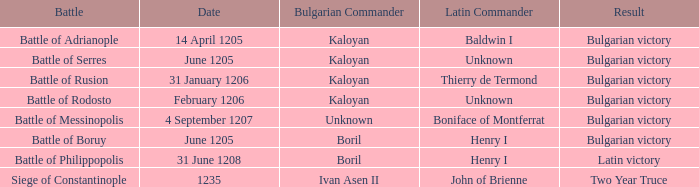On what Date was Henry I Latin Commander of the Battle of Boruy? June 1205. 